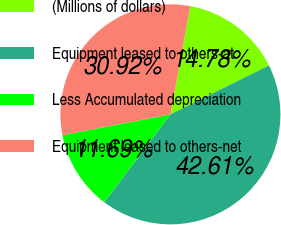<chart> <loc_0><loc_0><loc_500><loc_500><pie_chart><fcel>(Millions of dollars)<fcel>Equipment leased to others-at<fcel>Less Accumulated depreciation<fcel>Equipment leased to others-net<nl><fcel>14.78%<fcel>42.61%<fcel>11.69%<fcel>30.92%<nl></chart> 